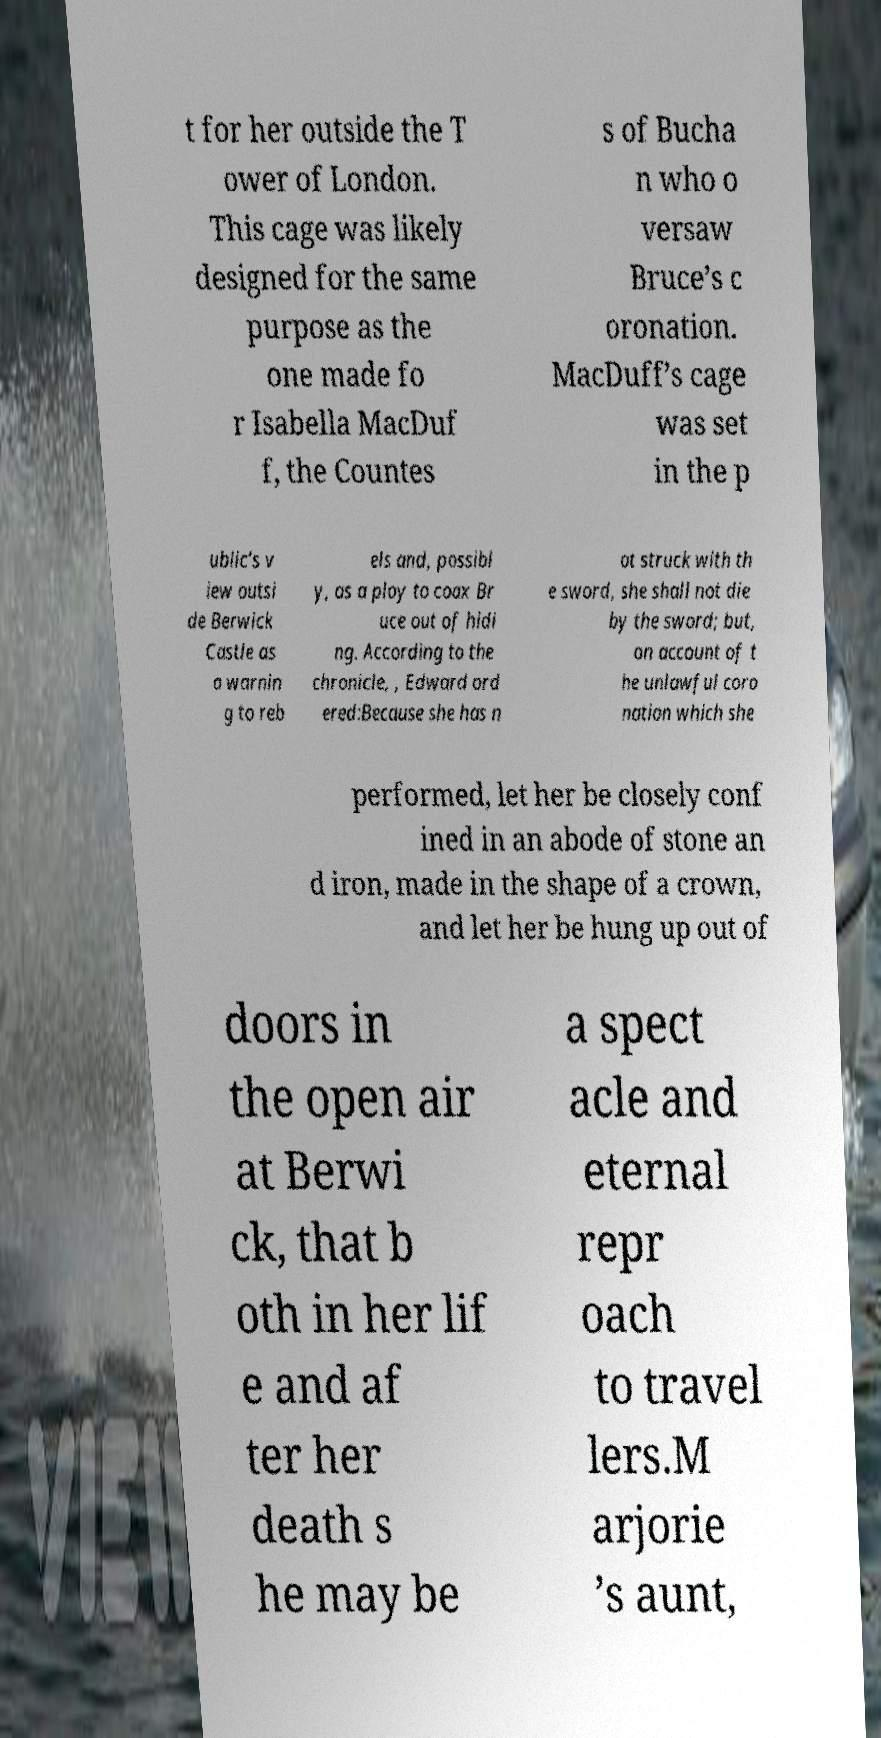What messages or text are displayed in this image? I need them in a readable, typed format. t for her outside the T ower of London. This cage was likely designed for the same purpose as the one made fo r Isabella MacDuf f, the Countes s of Bucha n who o versaw Bruce’s c oronation. MacDuff’s cage was set in the p ublic’s v iew outsi de Berwick Castle as a warnin g to reb els and, possibl y, as a ploy to coax Br uce out of hidi ng. According to the chronicle, , Edward ord ered:Because she has n ot struck with th e sword, she shall not die by the sword; but, on account of t he unlawful coro nation which she performed, let her be closely conf ined in an abode of stone an d iron, made in the shape of a crown, and let her be hung up out of doors in the open air at Berwi ck, that b oth in her lif e and af ter her death s he may be a spect acle and eternal repr oach to travel lers.M arjorie ’s aunt, 